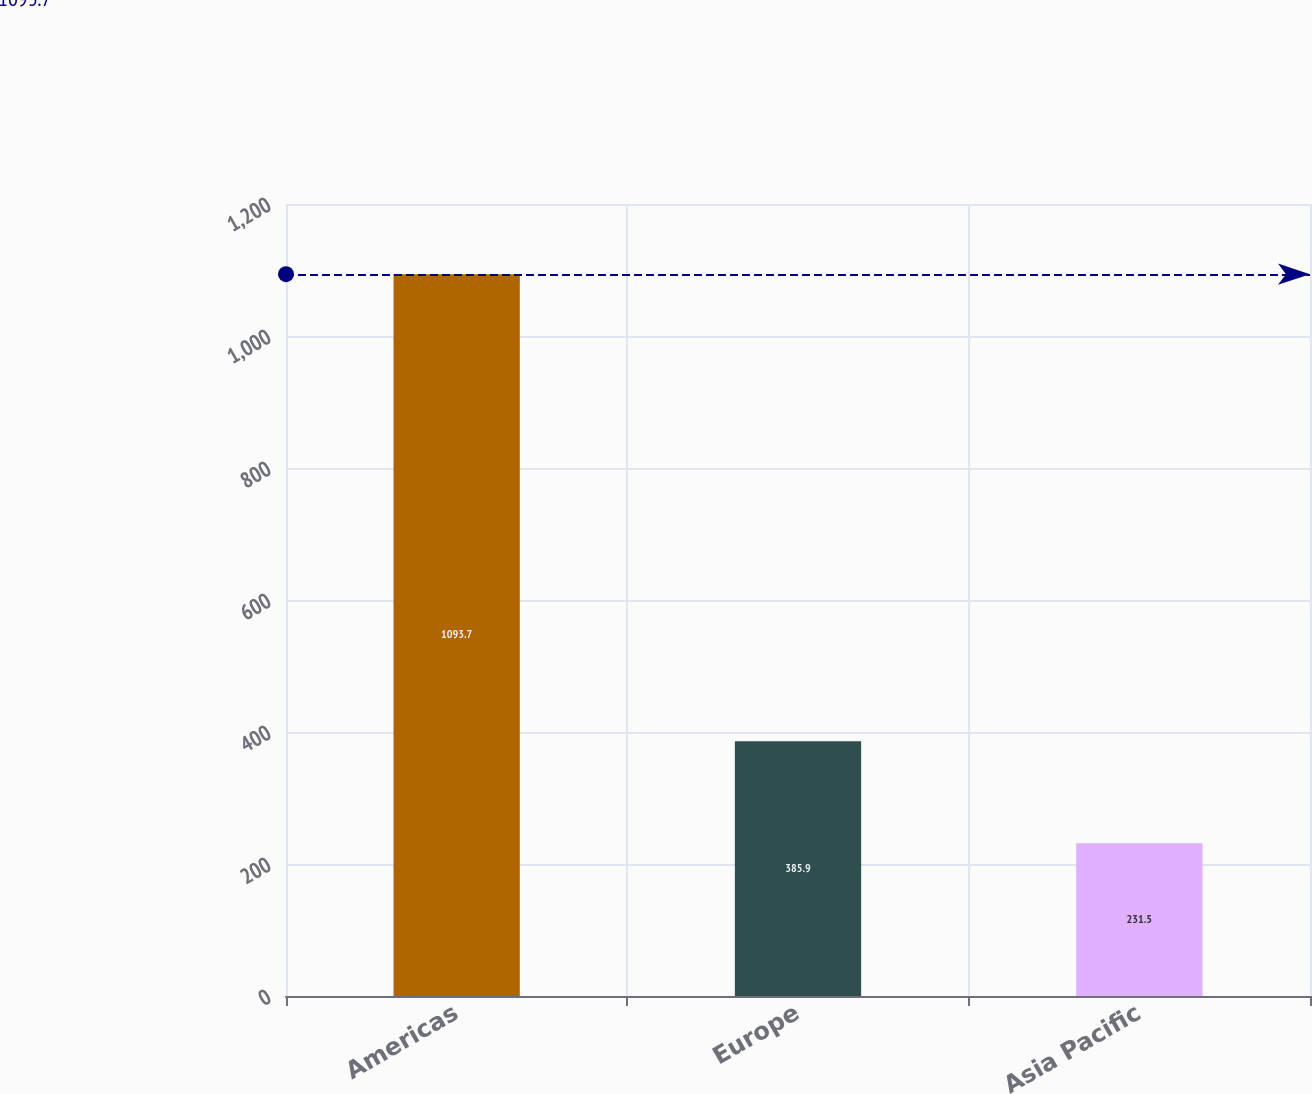Convert chart to OTSL. <chart><loc_0><loc_0><loc_500><loc_500><bar_chart><fcel>Americas<fcel>Europe<fcel>Asia Pacific<nl><fcel>1093.7<fcel>385.9<fcel>231.5<nl></chart> 